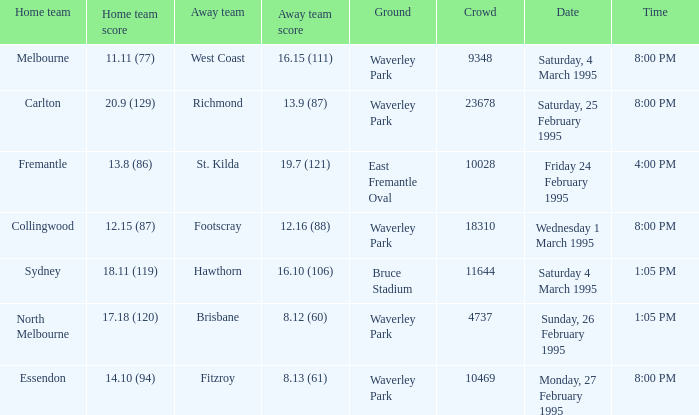Name the ground for essendon Waverley Park. 